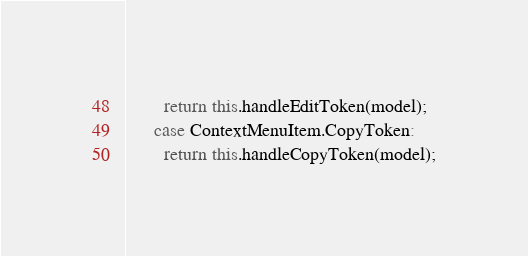Convert code to text. <code><loc_0><loc_0><loc_500><loc_500><_TypeScript_>        return this.handleEditToken(model);
      case ContextMenuItem.CopyToken:
        return this.handleCopyToken(model);</code> 